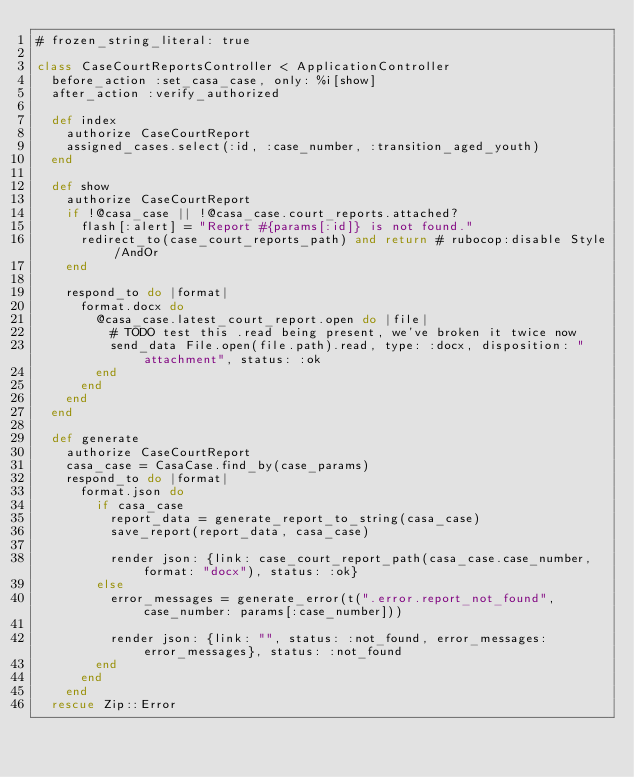<code> <loc_0><loc_0><loc_500><loc_500><_Ruby_># frozen_string_literal: true

class CaseCourtReportsController < ApplicationController
  before_action :set_casa_case, only: %i[show]
  after_action :verify_authorized

  def index
    authorize CaseCourtReport
    assigned_cases.select(:id, :case_number, :transition_aged_youth)
  end

  def show
    authorize CaseCourtReport
    if !@casa_case || !@casa_case.court_reports.attached?
      flash[:alert] = "Report #{params[:id]} is not found."
      redirect_to(case_court_reports_path) and return # rubocop:disable Style/AndOr
    end

    respond_to do |format|
      format.docx do
        @casa_case.latest_court_report.open do |file|
          # TODO test this .read being present, we've broken it twice now
          send_data File.open(file.path).read, type: :docx, disposition: "attachment", status: :ok
        end
      end
    end
  end

  def generate
    authorize CaseCourtReport
    casa_case = CasaCase.find_by(case_params)
    respond_to do |format|
      format.json do
        if casa_case
          report_data = generate_report_to_string(casa_case)
          save_report(report_data, casa_case)

          render json: {link: case_court_report_path(casa_case.case_number, format: "docx"), status: :ok}
        else
          error_messages = generate_error(t(".error.report_not_found", case_number: params[:case_number]))

          render json: {link: "", status: :not_found, error_messages: error_messages}, status: :not_found
        end
      end
    end
  rescue Zip::Error</code> 